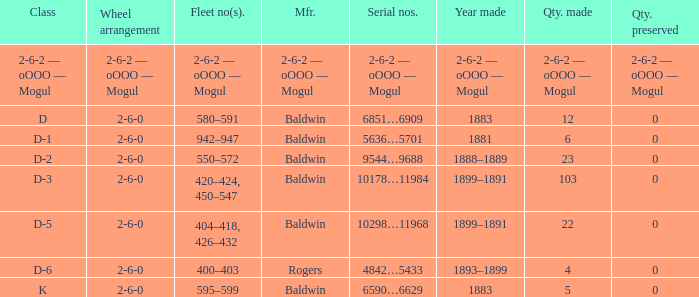What is the wheel arrangement when the year made is 1881? 2-6-0. 